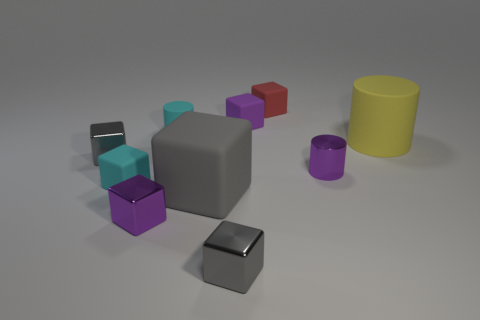Subtract all gray cubes. How many were subtracted if there are1gray cubes left? 2 Subtract all yellow cylinders. How many gray cubes are left? 3 Subtract 2 blocks. How many blocks are left? 5 Subtract all gray blocks. How many blocks are left? 4 Subtract all red blocks. How many blocks are left? 6 Subtract all cyan blocks. Subtract all purple cylinders. How many blocks are left? 6 Subtract all cylinders. How many objects are left? 7 Add 1 small cyan cylinders. How many small cyan cylinders exist? 2 Subtract 0 gray cylinders. How many objects are left? 10 Subtract all cyan rubber things. Subtract all purple rubber cubes. How many objects are left? 7 